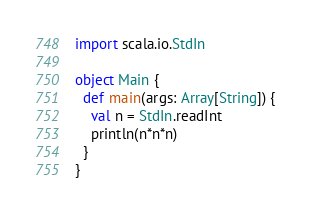<code> <loc_0><loc_0><loc_500><loc_500><_Scala_>import scala.io.StdIn

object Main {
  def main(args: Array[String]) {
    val n = StdIn.readInt
    println(n*n*n)
  }
}</code> 